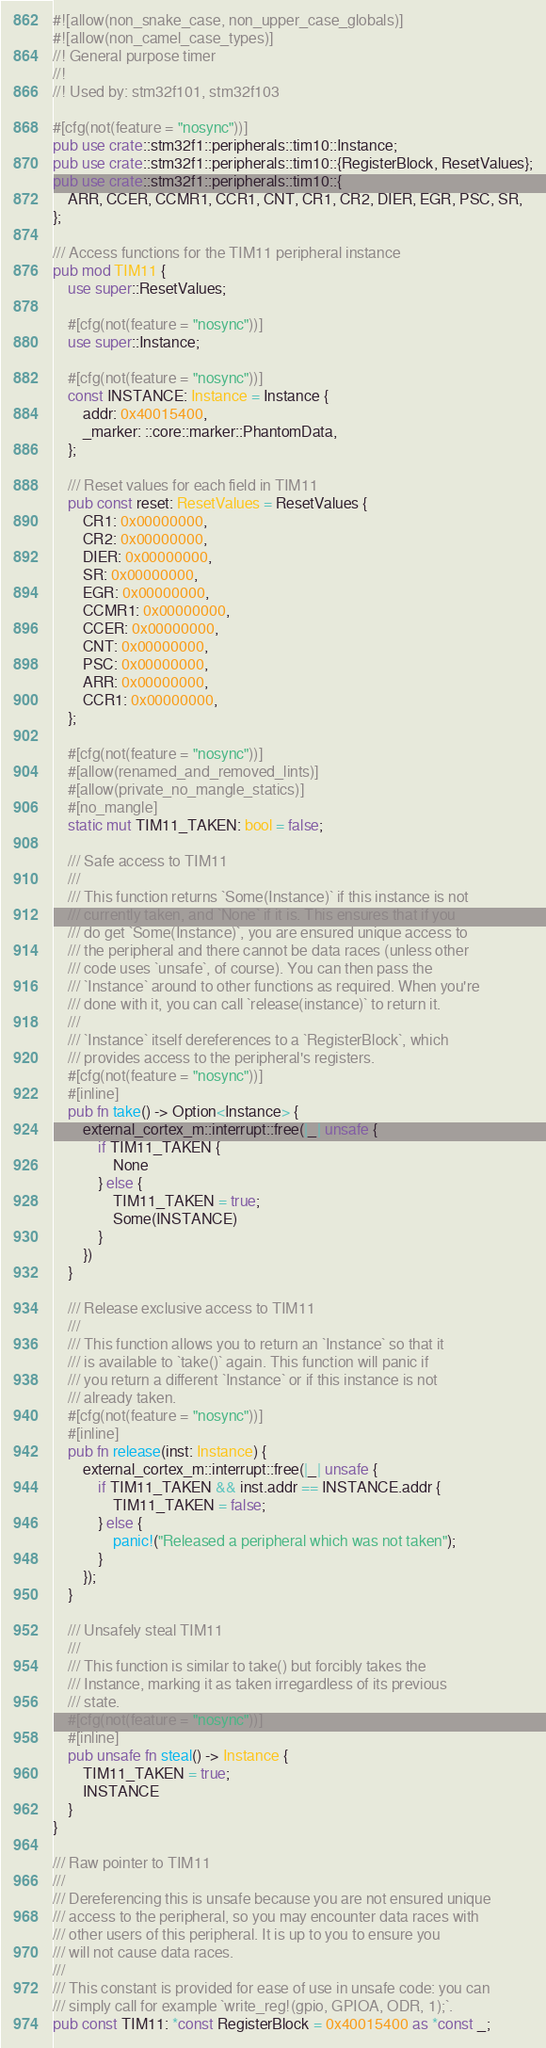<code> <loc_0><loc_0><loc_500><loc_500><_Rust_>#![allow(non_snake_case, non_upper_case_globals)]
#![allow(non_camel_case_types)]
//! General purpose timer
//!
//! Used by: stm32f101, stm32f103

#[cfg(not(feature = "nosync"))]
pub use crate::stm32f1::peripherals::tim10::Instance;
pub use crate::stm32f1::peripherals::tim10::{RegisterBlock, ResetValues};
pub use crate::stm32f1::peripherals::tim10::{
    ARR, CCER, CCMR1, CCR1, CNT, CR1, CR2, DIER, EGR, PSC, SR,
};

/// Access functions for the TIM11 peripheral instance
pub mod TIM11 {
    use super::ResetValues;

    #[cfg(not(feature = "nosync"))]
    use super::Instance;

    #[cfg(not(feature = "nosync"))]
    const INSTANCE: Instance = Instance {
        addr: 0x40015400,
        _marker: ::core::marker::PhantomData,
    };

    /// Reset values for each field in TIM11
    pub const reset: ResetValues = ResetValues {
        CR1: 0x00000000,
        CR2: 0x00000000,
        DIER: 0x00000000,
        SR: 0x00000000,
        EGR: 0x00000000,
        CCMR1: 0x00000000,
        CCER: 0x00000000,
        CNT: 0x00000000,
        PSC: 0x00000000,
        ARR: 0x00000000,
        CCR1: 0x00000000,
    };

    #[cfg(not(feature = "nosync"))]
    #[allow(renamed_and_removed_lints)]
    #[allow(private_no_mangle_statics)]
    #[no_mangle]
    static mut TIM11_TAKEN: bool = false;

    /// Safe access to TIM11
    ///
    /// This function returns `Some(Instance)` if this instance is not
    /// currently taken, and `None` if it is. This ensures that if you
    /// do get `Some(Instance)`, you are ensured unique access to
    /// the peripheral and there cannot be data races (unless other
    /// code uses `unsafe`, of course). You can then pass the
    /// `Instance` around to other functions as required. When you're
    /// done with it, you can call `release(instance)` to return it.
    ///
    /// `Instance` itself dereferences to a `RegisterBlock`, which
    /// provides access to the peripheral's registers.
    #[cfg(not(feature = "nosync"))]
    #[inline]
    pub fn take() -> Option<Instance> {
        external_cortex_m::interrupt::free(|_| unsafe {
            if TIM11_TAKEN {
                None
            } else {
                TIM11_TAKEN = true;
                Some(INSTANCE)
            }
        })
    }

    /// Release exclusive access to TIM11
    ///
    /// This function allows you to return an `Instance` so that it
    /// is available to `take()` again. This function will panic if
    /// you return a different `Instance` or if this instance is not
    /// already taken.
    #[cfg(not(feature = "nosync"))]
    #[inline]
    pub fn release(inst: Instance) {
        external_cortex_m::interrupt::free(|_| unsafe {
            if TIM11_TAKEN && inst.addr == INSTANCE.addr {
                TIM11_TAKEN = false;
            } else {
                panic!("Released a peripheral which was not taken");
            }
        });
    }

    /// Unsafely steal TIM11
    ///
    /// This function is similar to take() but forcibly takes the
    /// Instance, marking it as taken irregardless of its previous
    /// state.
    #[cfg(not(feature = "nosync"))]
    #[inline]
    pub unsafe fn steal() -> Instance {
        TIM11_TAKEN = true;
        INSTANCE
    }
}

/// Raw pointer to TIM11
///
/// Dereferencing this is unsafe because you are not ensured unique
/// access to the peripheral, so you may encounter data races with
/// other users of this peripheral. It is up to you to ensure you
/// will not cause data races.
///
/// This constant is provided for ease of use in unsafe code: you can
/// simply call for example `write_reg!(gpio, GPIOA, ODR, 1);`.
pub const TIM11: *const RegisterBlock = 0x40015400 as *const _;
</code> 